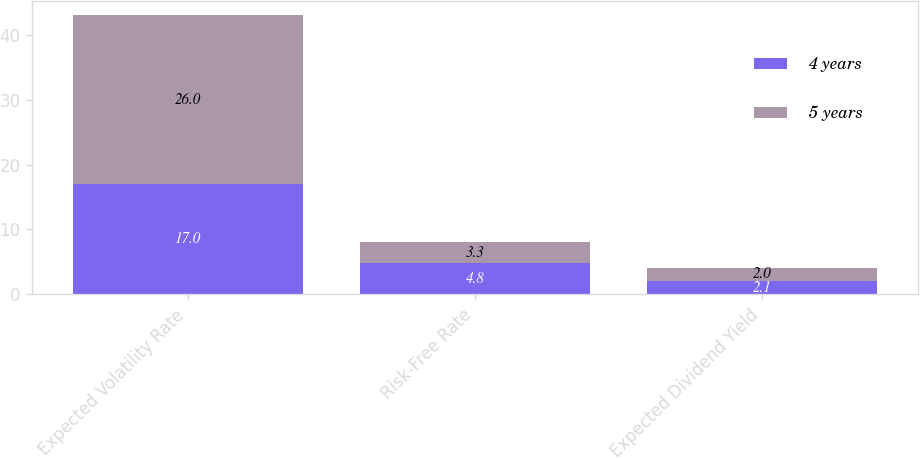Convert chart to OTSL. <chart><loc_0><loc_0><loc_500><loc_500><stacked_bar_chart><ecel><fcel>Expected Volatility Rate<fcel>Risk-Free Rate<fcel>Expected Dividend Yield<nl><fcel>4 years<fcel>17<fcel>4.8<fcel>2.1<nl><fcel>5 years<fcel>26<fcel>3.3<fcel>2<nl></chart> 